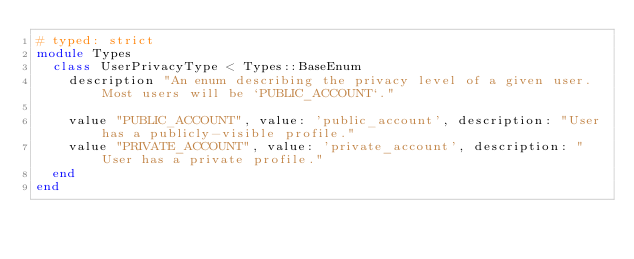<code> <loc_0><loc_0><loc_500><loc_500><_Ruby_># typed: strict
module Types
  class UserPrivacyType < Types::BaseEnum
    description "An enum describing the privacy level of a given user. Most users will be `PUBLIC_ACCOUNT`."

    value "PUBLIC_ACCOUNT", value: 'public_account', description: "User has a publicly-visible profile."
    value "PRIVATE_ACCOUNT", value: 'private_account', description: "User has a private profile."
  end
end
</code> 